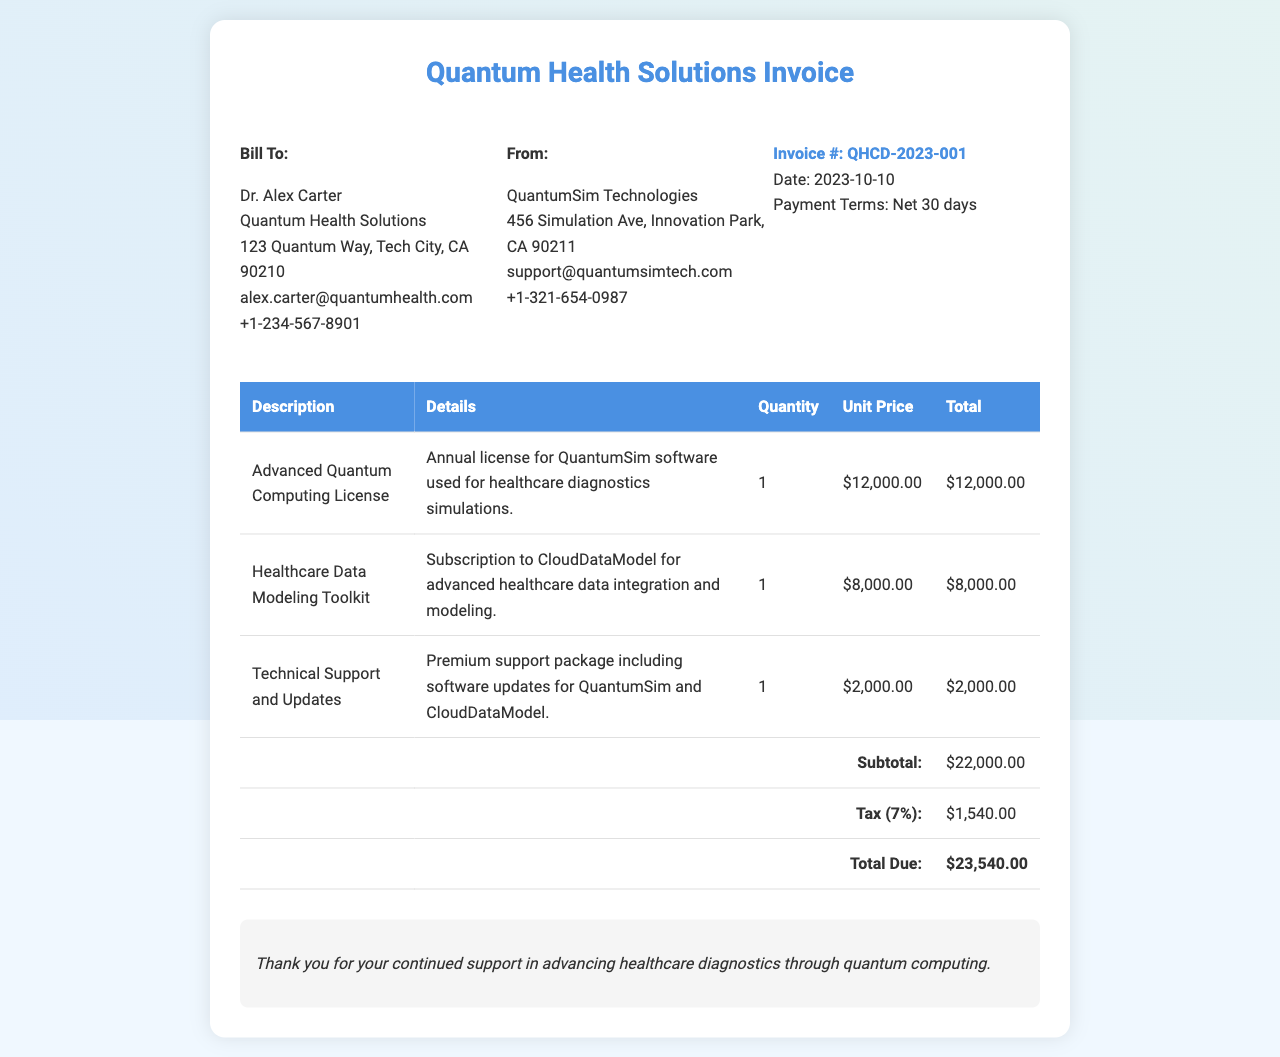What is the invoice number? The invoice number is a unique identifier for the invoice and is found in the invoice details section.
Answer: QHCD-2023-001 Who is the billing recipient? The billing recipient refers to the individual or organization receiving the invoice. This information is located in the "Bill To" section.
Answer: Dr. Alex Carter What is the total due amount? The total due amount is the final sum to be paid, calculated at the bottom of the invoice under "Total Due."
Answer: $23,540.00 What is the date of the invoice? The date of the invoice is important for payment scheduling and is mentioned in the invoice details.
Answer: 2023-10-10 How much is the tax rate applied? The tax rate is provided alongside the calculation in the invoice, indicating the percentage applied to the subtotal.
Answer: 7% What services are covered by the premium support package? The premium support package includes specific services mentioned in the invoice under technical support and updates.
Answer: Software updates How many units of the Advanced Quantum Computing License are billed? The quantity of the item billed provides insights into the services acquired, which is specified in the invoice itemization.
Answer: 1 What is the subtotal before taxes? The subtotal defines the sum of all line items before tax is applied, listed in the invoice table.
Answer: $22,000.00 What does the note at the bottom thank the recipient for? The invoice includes a note thanking the recipient for their support, which conveys appreciation for continued business.
Answer: Advancing healthcare diagnostics through quantum computing 